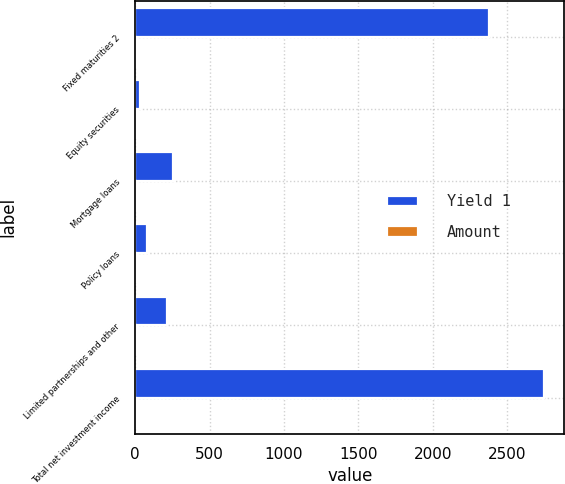Convert chart. <chart><loc_0><loc_0><loc_500><loc_500><stacked_bar_chart><ecel><fcel>Fixed maturities 2<fcel>Equity securities<fcel>Mortgage loans<fcel>Policy loans<fcel>Limited partnerships and other<fcel>Total net investment income<nl><fcel>Yield 1<fcel>2379<fcel>31<fcel>252<fcel>83<fcel>214<fcel>2747<nl><fcel>Amount<fcel>4.2<fcel>3.4<fcel>4.5<fcel>5.8<fcel>8.5<fcel>4.1<nl></chart> 